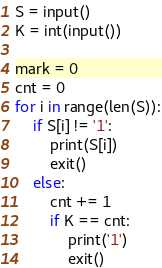Convert code to text. <code><loc_0><loc_0><loc_500><loc_500><_Python_>S = input()
K = int(input())

mark = 0
cnt = 0
for i in range(len(S)):
    if S[i] != '1':
        print(S[i])
        exit()
    else:
        cnt += 1
        if K == cnt:
            print('1')
            exit()
</code> 